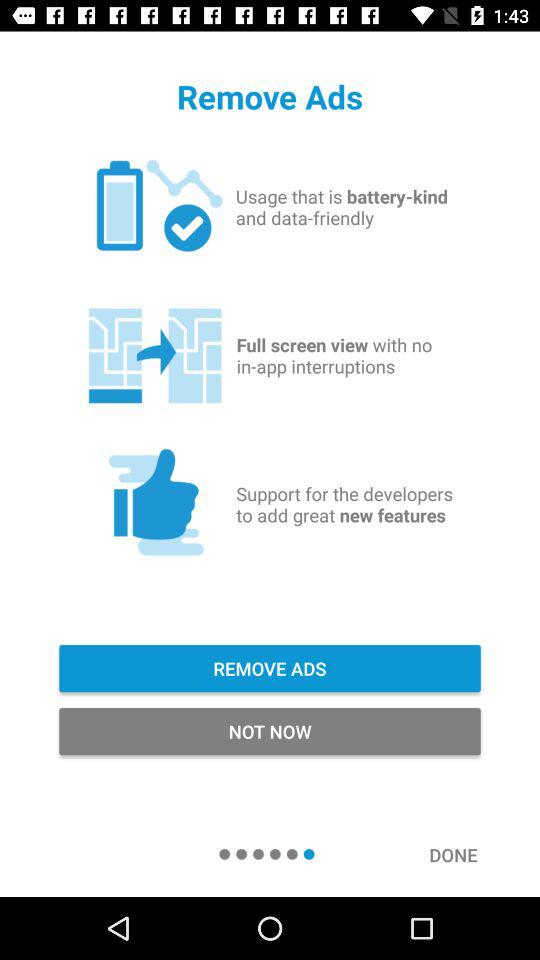Which option is selected?
When the provided information is insufficient, respond with <no answer>. <no answer> 